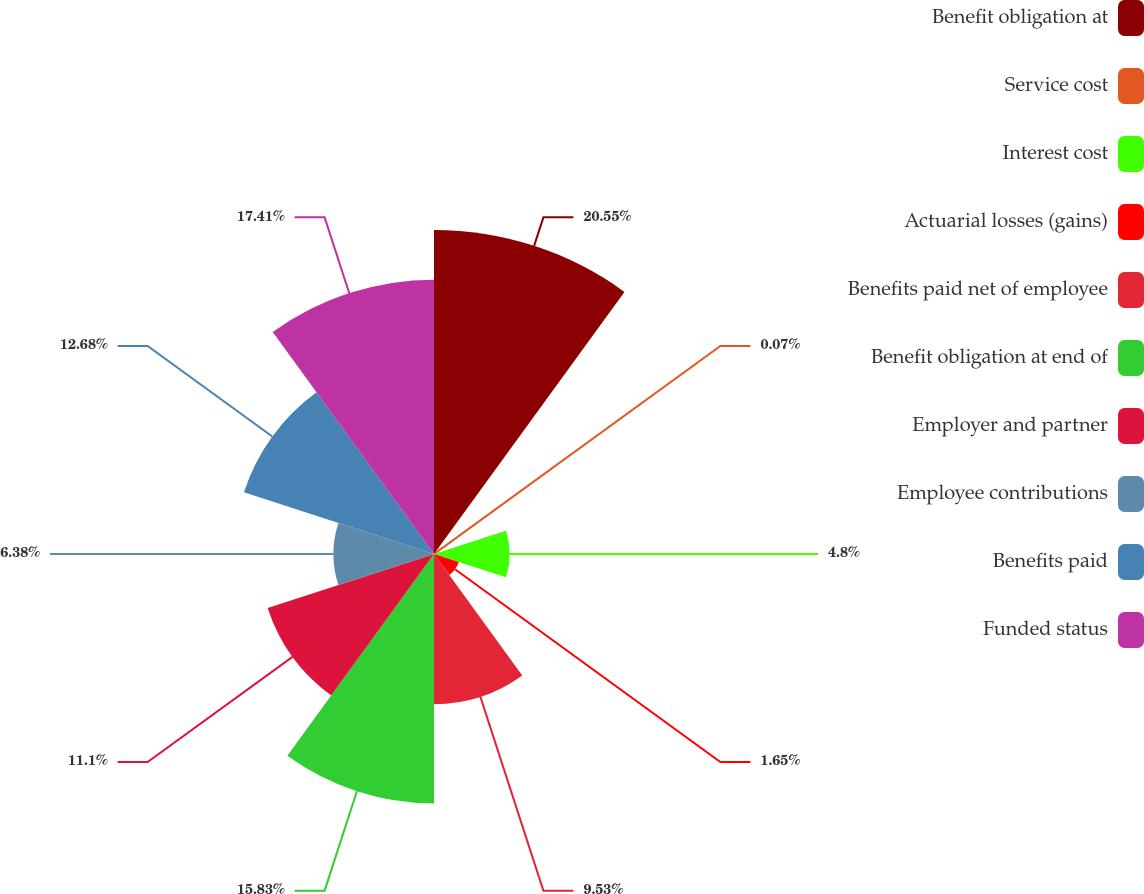<chart> <loc_0><loc_0><loc_500><loc_500><pie_chart><fcel>Benefit obligation at<fcel>Service cost<fcel>Interest cost<fcel>Actuarial losses (gains)<fcel>Benefits paid net of employee<fcel>Benefit obligation at end of<fcel>Employer and partner<fcel>Employee contributions<fcel>Benefits paid<fcel>Funded status<nl><fcel>20.56%<fcel>0.07%<fcel>4.8%<fcel>1.65%<fcel>9.53%<fcel>15.83%<fcel>11.1%<fcel>6.38%<fcel>12.68%<fcel>17.41%<nl></chart> 